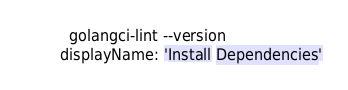<code> <loc_0><loc_0><loc_500><loc_500><_YAML_>      golangci-lint --version
    displayName: 'Install Dependencies'
</code> 